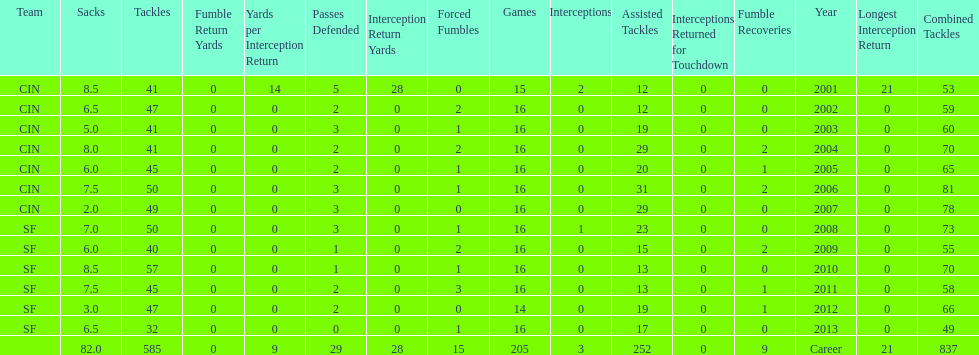What is the only season he has fewer than three sacks? 2007. 